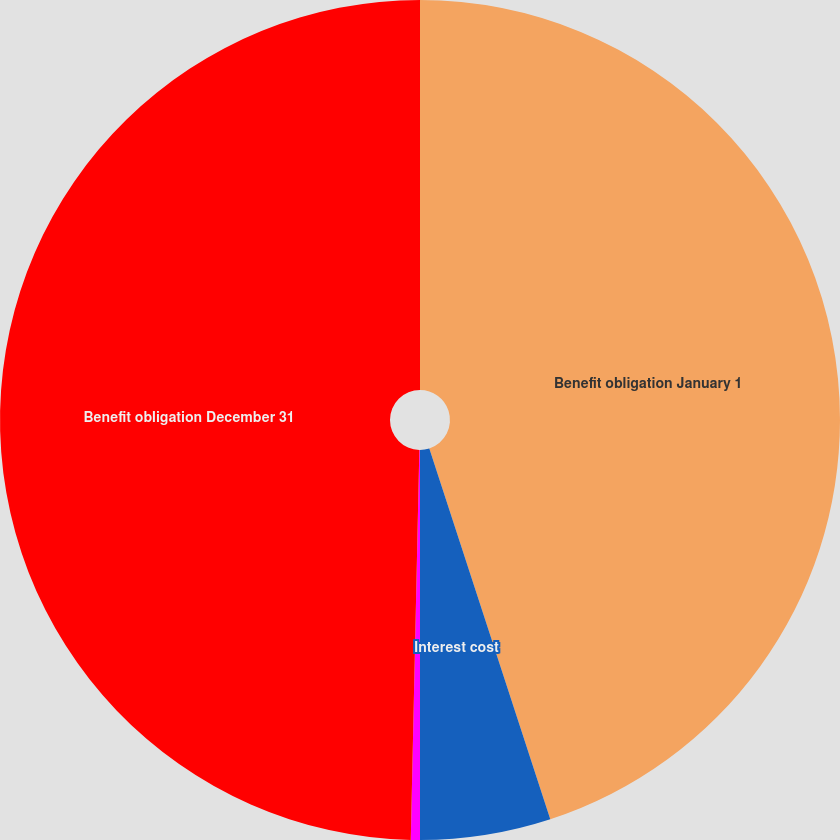<chart> <loc_0><loc_0><loc_500><loc_500><pie_chart><fcel>Benefit obligation January 1<fcel>Interest cost<fcel>Benefits paid<fcel>Benefit obligation December 31<nl><fcel>44.98%<fcel>5.02%<fcel>0.35%<fcel>49.65%<nl></chart> 